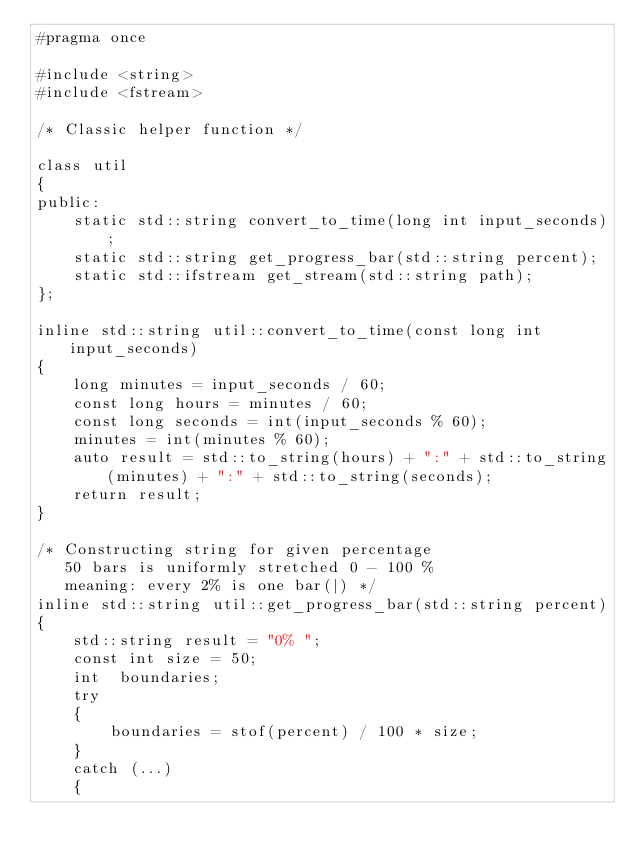<code> <loc_0><loc_0><loc_500><loc_500><_C_>#pragma once

#include <string>
#include <fstream>

/* Classic helper function */

class util 
{
public:
	static std::string convert_to_time(long int input_seconds);
	static std::string get_progress_bar(std::string percent);
	static std::ifstream get_stream(std::string path);
};

inline std::string util::convert_to_time(const long int input_seconds) 
{
	long minutes = input_seconds / 60;
	const long hours = minutes / 60;
	const long seconds = int(input_seconds % 60);
	minutes = int(minutes % 60);
	auto result = std::to_string(hours) + ":" + std::to_string(minutes) + ":" + std::to_string(seconds);
	return result;
}

/* Constructing string for given percentage
   50 bars is uniformly stretched 0 - 100 %
   meaning: every 2% is one bar(|) */
inline std::string util::get_progress_bar(std::string percent) 
{
	std::string result = "0% ";
	const int size = 50;
	int  boundaries;
	try 
	{
		boundaries = stof(percent) / 100 * size;
	}
	catch (...) 
	{</code> 